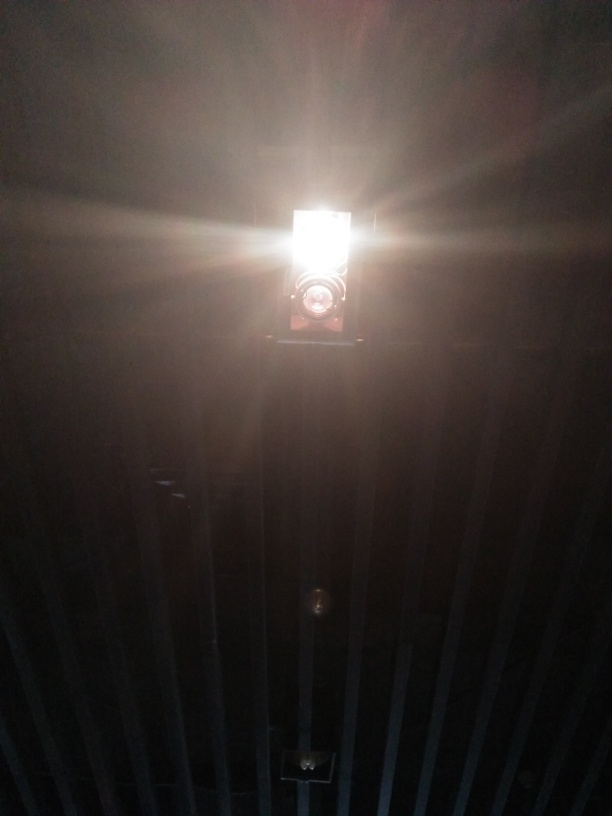Is the overall clarity of the image very low? The image has a significant glare from a light source, causing a loss of detail in the surroundings and giving an appearance of low clarity. However, the outline of the light fixture and some structural elements are still discernible. 